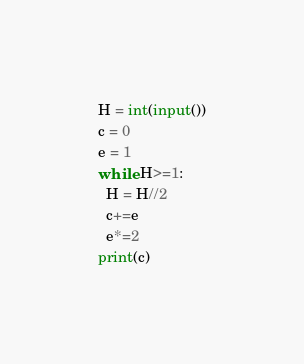<code> <loc_0><loc_0><loc_500><loc_500><_Python_>H = int(input())
c = 0
e = 1
while H>=1:
  H = H//2
  c+=e
  e*=2
print(c)</code> 